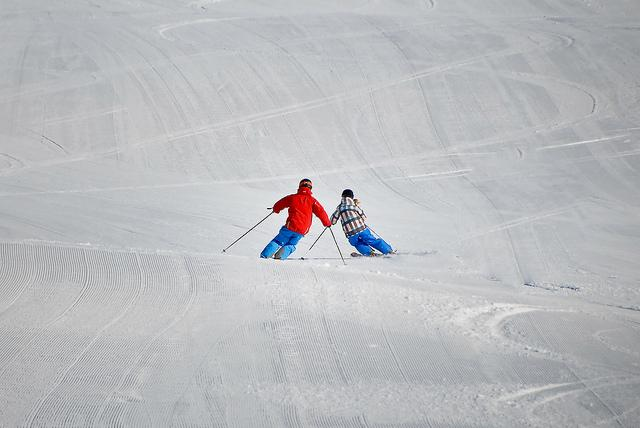What type of action are the people taking?

Choices:
A) retreat
B) ascend
C) descent
D) attack descent 